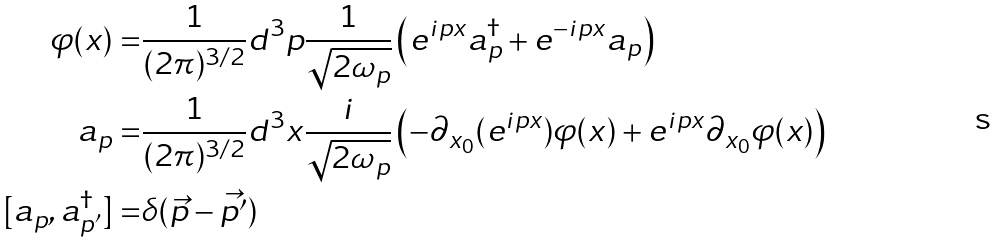<formula> <loc_0><loc_0><loc_500><loc_500>\varphi ( x ) = & \frac { 1 } { ( 2 \pi ) ^ { 3 / 2 } } d ^ { 3 } p \frac { 1 } { \sqrt { 2 \omega _ { p } } } \left ( e ^ { i p x } a _ { p } ^ { \dagger } + e ^ { - i p x } a _ { p } \right ) \\ a _ { p } = & \frac { 1 } { ( 2 \pi ) ^ { 3 / 2 } } d ^ { 3 } x \frac { i } { \sqrt { 2 \omega _ { p } } } \left ( - \partial _ { x _ { 0 } } ( e ^ { i p x } ) \varphi ( x ) + e ^ { i p x } \partial _ { x _ { 0 } } \varphi ( x ) \right ) \\ [ a _ { p } , a _ { p ^ { \prime } } ^ { \dagger } ] = & \delta ( \vec { p } - \vec { p ^ { \prime } } )</formula> 